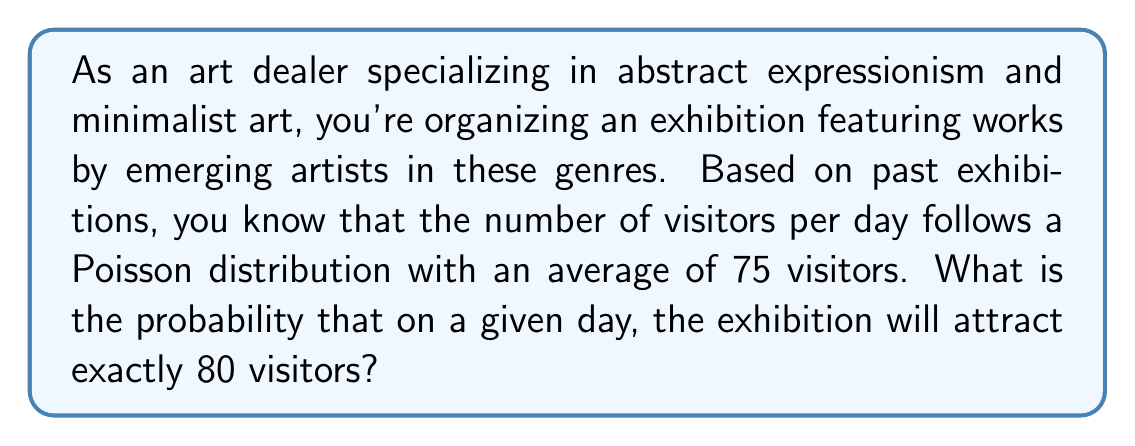Help me with this question. To solve this problem, we need to use the Poisson distribution formula. The Poisson distribution is used to model the number of events occurring in a fixed interval of time or space, given a known average rate.

The Poisson probability mass function is given by:

$$P(X = k) = \frac{e^{-\lambda} \lambda^k}{k!}$$

Where:
$\lambda$ = the average number of events in the interval
$k$ = the number of events we're calculating the probability for
$e$ = Euler's number (approximately 2.71828)

In this case:
$\lambda = 75$ (average number of visitors per day)
$k = 80$ (the specific number of visitors we're calculating the probability for)

Let's substitute these values into the formula:

$$P(X = 80) = \frac{e^{-75} 75^{80}}{80!}$$

To calculate this:

1. Calculate $e^{-75}$ ≈ 3.1543 × 10^(-33)
2. Calculate $75^{80}$ ≈ 2.2459 × 10^148
3. Calculate 80! ≈ 7.1569 × 10^118
4. Multiply the numerator: 3.1543 × 10^(-33) × 2.2459 × 10^148 ≈ 7.0842 × 10^115
5. Divide by the denominator: (7.0842 × 10^115) / (7.1569 × 10^118) ≈ 0.0099

Therefore, the probability of exactly 80 visitors in a day is approximately 0.0099 or 0.99%.
Answer: The probability that the exhibition will attract exactly 80 visitors on a given day is approximately 0.0099 or 0.99%. 